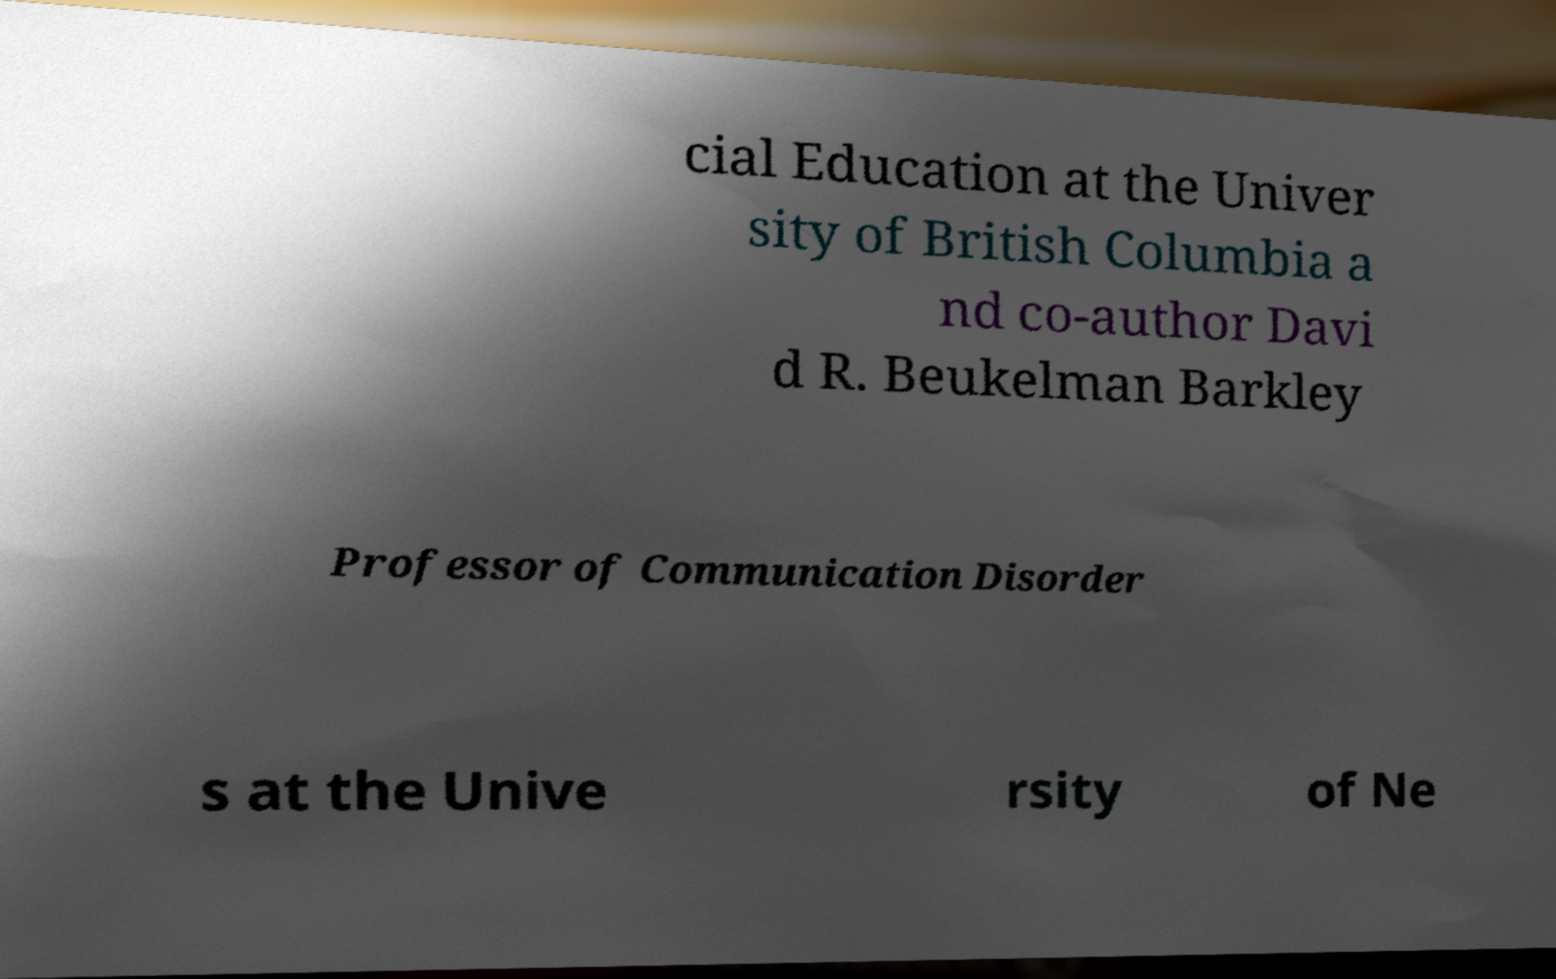Can you accurately transcribe the text from the provided image for me? cial Education at the Univer sity of British Columbia a nd co-author Davi d R. Beukelman Barkley Professor of Communication Disorder s at the Unive rsity of Ne 